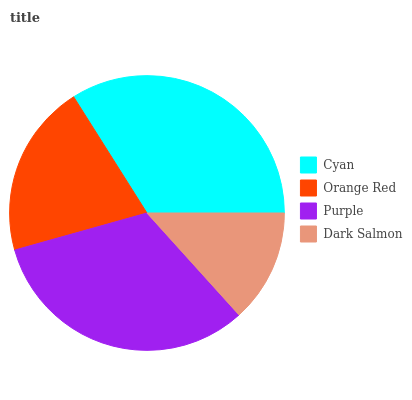Is Dark Salmon the minimum?
Answer yes or no. Yes. Is Cyan the maximum?
Answer yes or no. Yes. Is Orange Red the minimum?
Answer yes or no. No. Is Orange Red the maximum?
Answer yes or no. No. Is Cyan greater than Orange Red?
Answer yes or no. Yes. Is Orange Red less than Cyan?
Answer yes or no. Yes. Is Orange Red greater than Cyan?
Answer yes or no. No. Is Cyan less than Orange Red?
Answer yes or no. No. Is Purple the high median?
Answer yes or no. Yes. Is Orange Red the low median?
Answer yes or no. Yes. Is Orange Red the high median?
Answer yes or no. No. Is Cyan the low median?
Answer yes or no. No. 